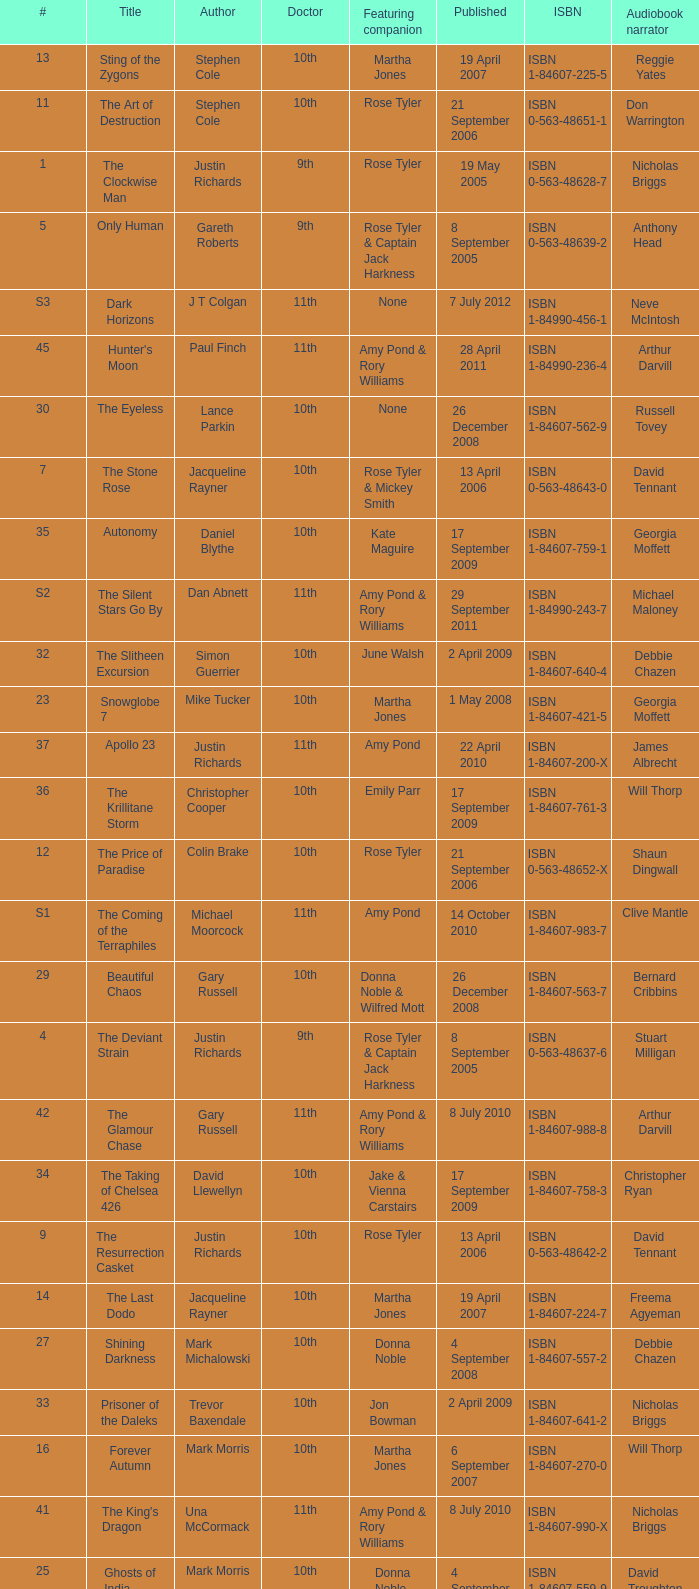What is the title of book number 8? The Feast of the Drowned. 